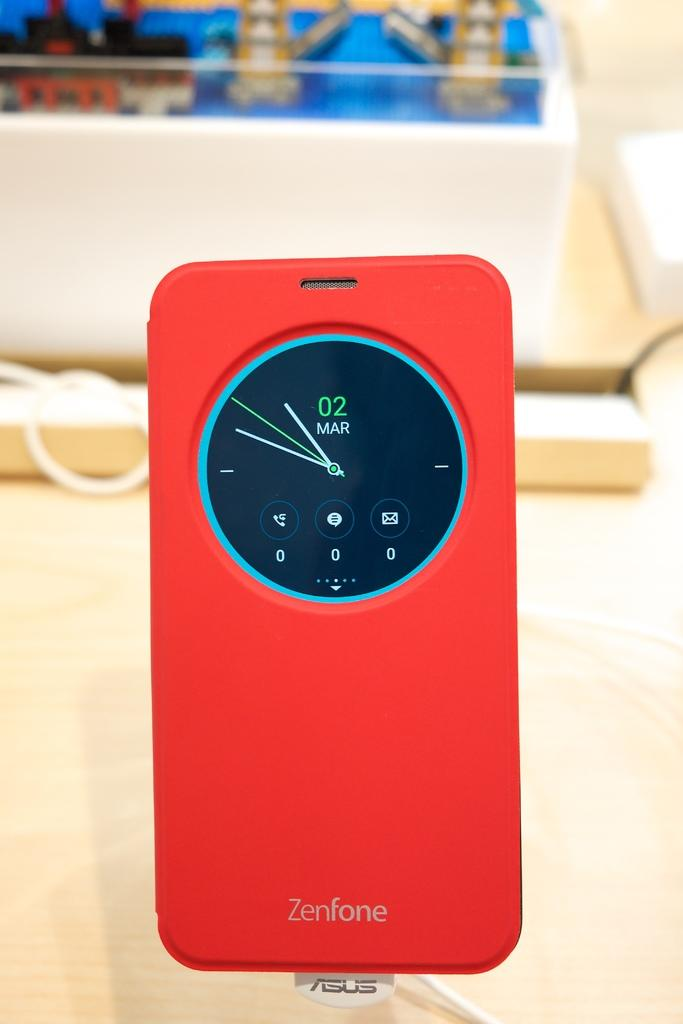<image>
Present a compact description of the photo's key features. A red Zenfone case has clock on the back with the date March 2. 